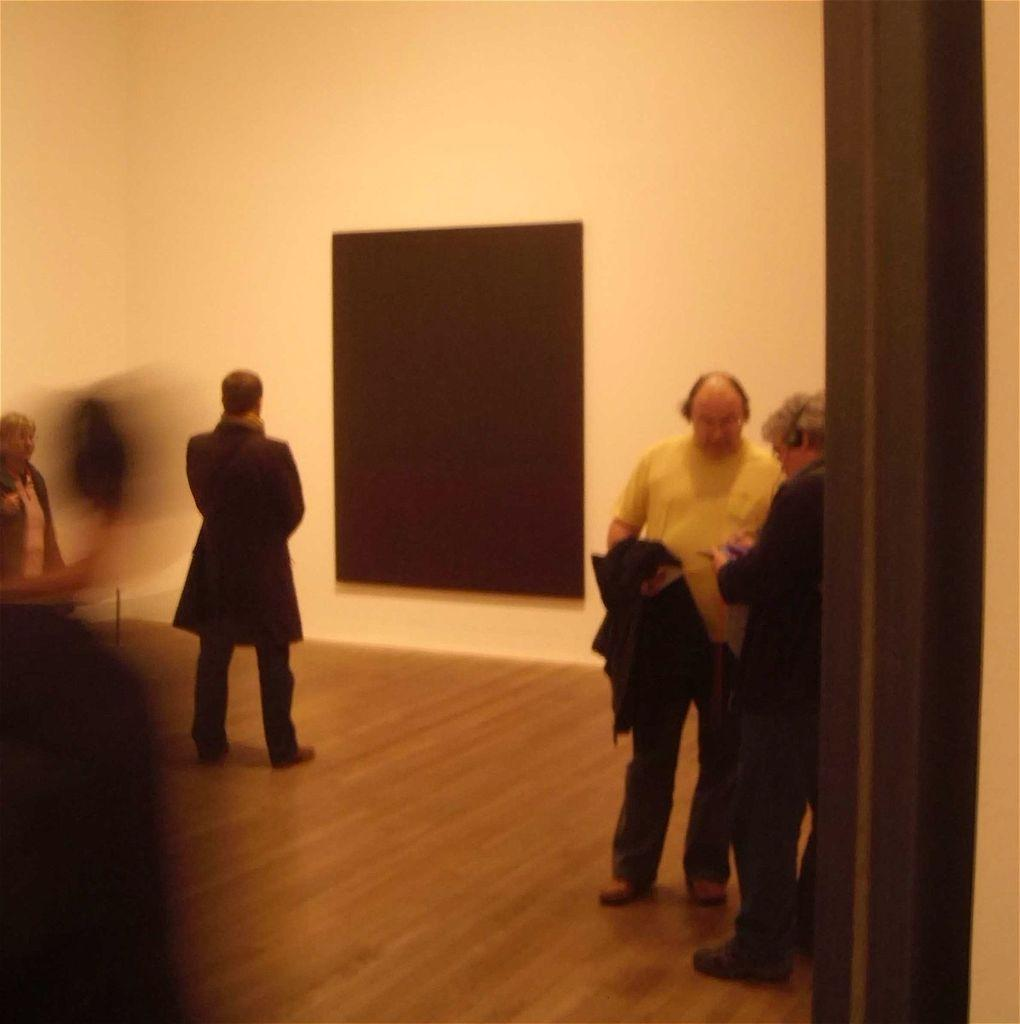How many people are in the image? There are four persons in the image. What is the position of the persons in the image? The persons are on the floor. What can be seen in the background of the image? There is a blackboard and a wall in the background of the image. What type of pancake is being served on the blackboard in the image? There is no pancake present on the blackboard or in the image. 